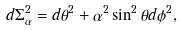<formula> <loc_0><loc_0><loc_500><loc_500>d \Sigma ^ { 2 } _ { \alpha } = d \theta ^ { 2 } + \alpha ^ { 2 } \sin ^ { 2 } \theta d \phi ^ { 2 } ,</formula> 